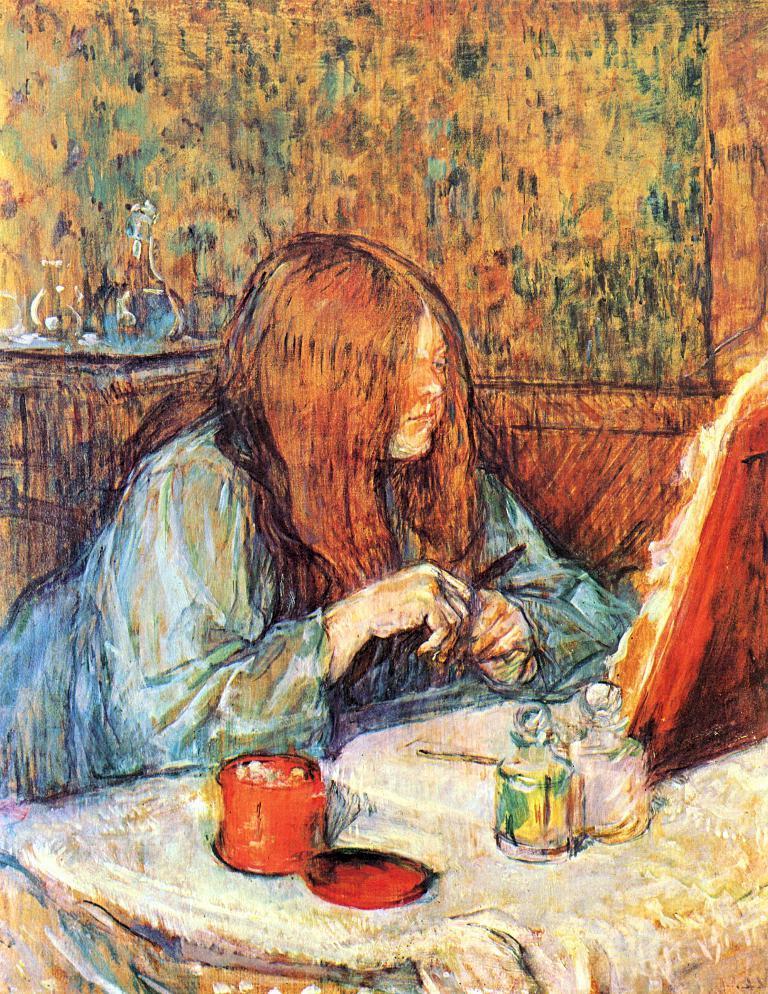Could you give a brief overview of what you see in this image? In this image there is a painting of a girl, in front of the girl there is a photo frame on the table, beside the photo frame there are a few objects, behind the girl there is a table. 